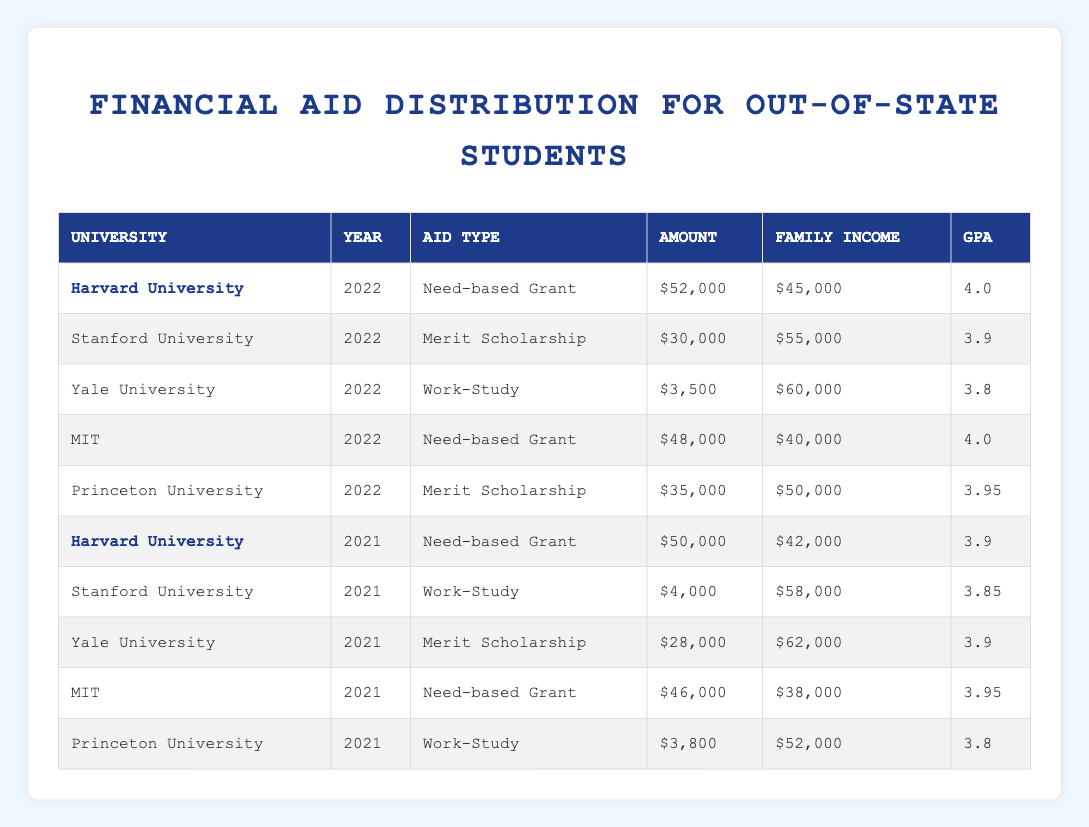What is the total amount of financial aid provided to students from Nebraska at Harvard University in 2022? The aid amount for Harvard University in 2022 is $52,000 as per the table. There is only one entry for Nebraska students in that year at Harvard.
Answer: 52000 How many different types of financial aid are given to students from Nebraska at Princeton University? Princeton University has two types of aid listed: "Merit Scholarship" in 2021 and "Merit Scholarship" in 2022, making it one type, as both are merit-based aid.
Answer: 1 What is the average financial aid amount received by Nebraska students at MIT over the years listed? The aid amounts for MIT are $48,000 in 2022 and $46,000 in 2021. To find the average, sum these amounts (48000 + 46000 = 94000) and divide by 2 (94000 / 2 = 47000).
Answer: 47000 Did Yale University provide any need-based grants to students from Nebraska? The table shows that Yale University provided a "Work-Study" in both 2021 and 2022 but not a need-based grant. Therefore, it is false that they provided need-based grants.
Answer: No Which university provided the highest amount of financial aid to Nebraska students in 2022? In 2022, Harvard University provided $52,000, which is higher than the amounts from other universities for that year: Stanford ($30,000), Yale ($3,500), MIT ($48,000), and Princeton ($35,000). So, Harvard provided the highest aid.
Answer: Harvard University What was the average GPA of students from Nebraska who received financial aid at Yale University in 2021 and 2022? The GPAs for Yale University in those years are 3.8 for 2022 and 3.9 for 2021. To find the average, sum these GPAs (3.8 + 3.9 = 7.7) and divide by 2 (7.7 / 2 = 3.85).
Answer: 3.85 Which university's aid amount decreased from 2021 to 2022 for students from Nebraska? Comparing year-over-year amounts for Nebraska students, Stanford's aid decreased from $4,000 in 2021 (Work-Study) to $30,000 in 2022 (Merit Scholarship). No aid amount decreased; in fact, it increased.
Answer: No decrease How much more financial aid did Princeton University provide in 2022 compared to 2021 to students from Nebraska? In 2021, Princeton provided $3,800 and in 2022 provided $35,000. The difference is calculated by subtracting 2021 from 2022 (35,000 - 3,800 = 31,200).
Answer: 31200 